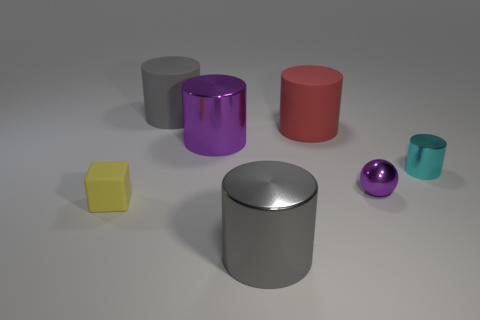Subtract all tiny cyan cylinders. How many cylinders are left? 4 Subtract all red cylinders. How many cylinders are left? 4 Subtract all yellow cylinders. Subtract all red blocks. How many cylinders are left? 5 Add 1 tiny cyan spheres. How many objects exist? 8 Subtract all cylinders. How many objects are left? 2 Add 6 big gray matte things. How many big gray matte things are left? 7 Add 2 large purple rubber things. How many large purple rubber things exist? 2 Subtract 0 yellow balls. How many objects are left? 7 Subtract all large purple rubber cylinders. Subtract all big gray metal objects. How many objects are left? 6 